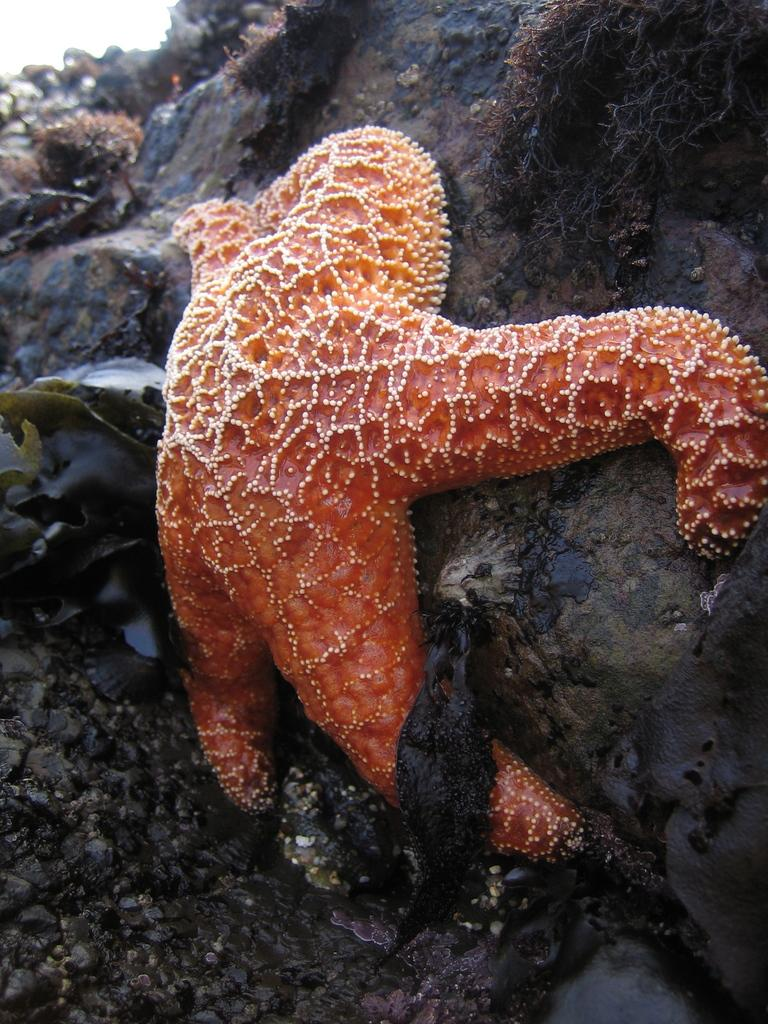What is the main subject of the image? There is an orange color starfish in the center of the image. Are there any other objects visible in the image besides the starfish? Yes, there are other objects visible in the image. What type of mist can be seen surrounding the airplane in the image? There is no airplane or mist present in the image; it features an orange color starfish and other unspecified objects. What type of guitar is being played by the person in the image? There is no person or guitar present in the image; it features an orange color starfish and other unspecified objects. 